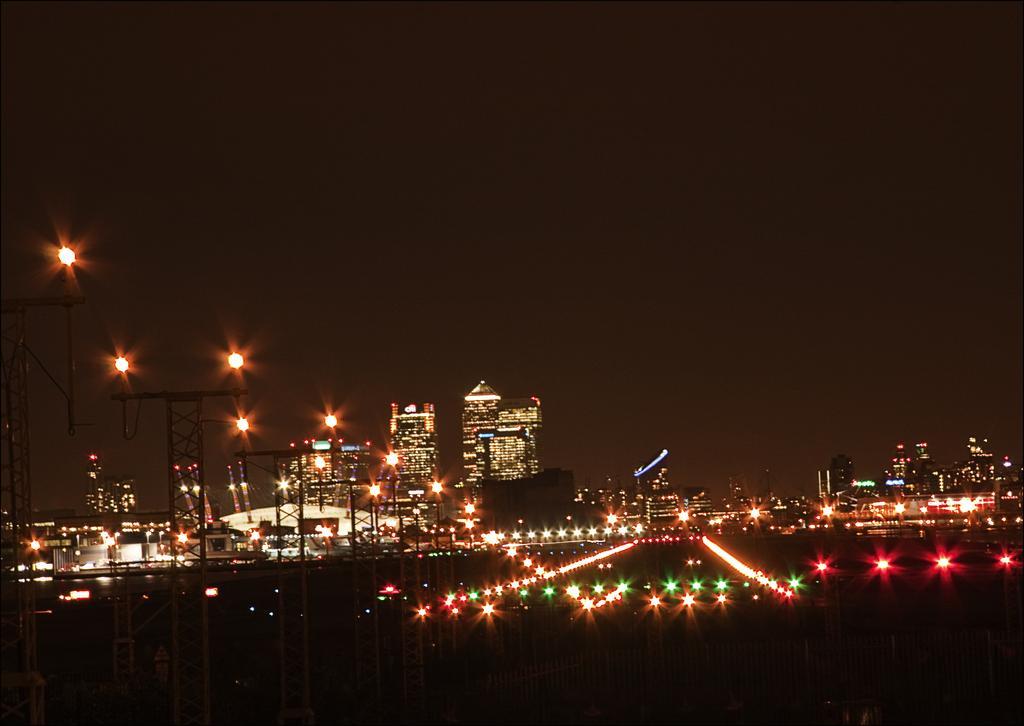In one or two sentences, can you explain what this image depicts? In this picture in the front on the left side there are poles and in the center there are lights. In the background there are buildings. 